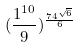Convert formula to latex. <formula><loc_0><loc_0><loc_500><loc_500>( \frac { 1 ^ { 1 0 } } { 9 } ) ^ { \frac { 7 4 ^ { \sqrt { 6 } } } { 6 } }</formula> 